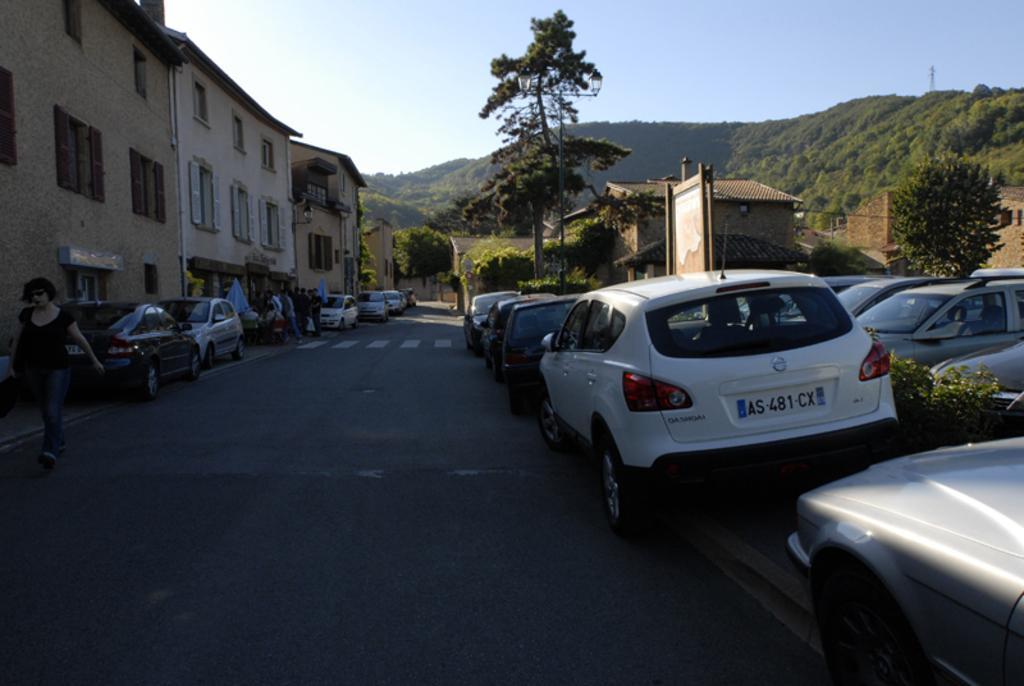How would you summarize this image in a sentence or two? In this image we can see there are cars on the road. And there are people, buildings, trees, mountain, board and the sky. 